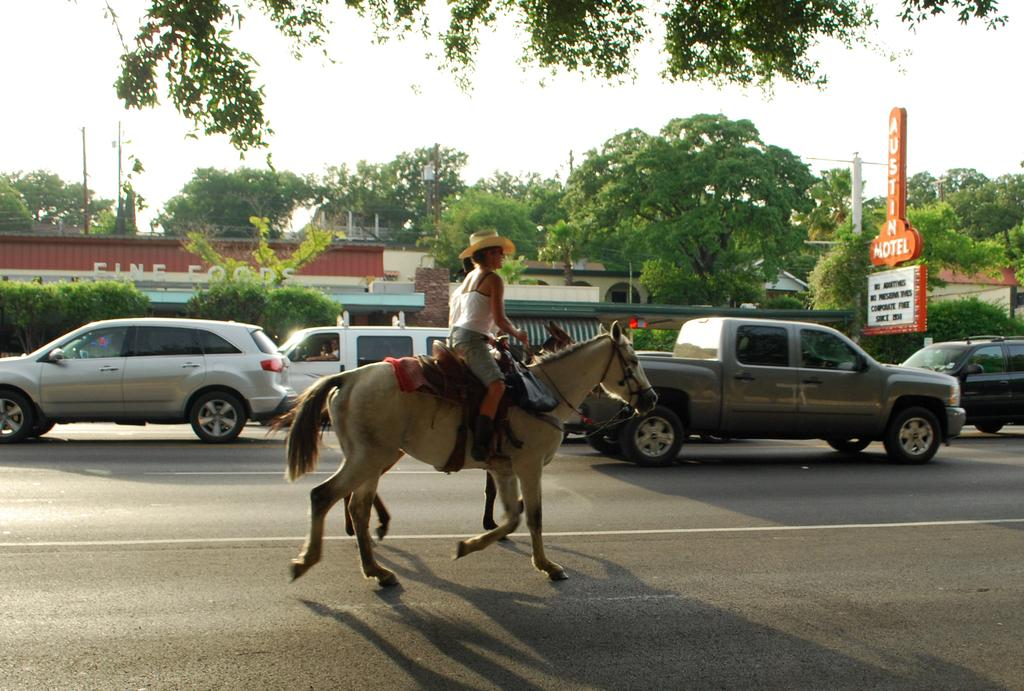What is the person in the image doing? The person is riding a horse in the image. What else can be seen on the ground in the image? There are vehicles on the road in the image. What structures are visible in the image? There are buildings in the image. What type of natural elements can be seen in the image? There are trees in the image. What is visible above the ground in the image? The sky is visible in the image. What type of arch can be seen in the image? There is no arch present in the image. How many churches can be seen in the image? There is no church present in the image. 